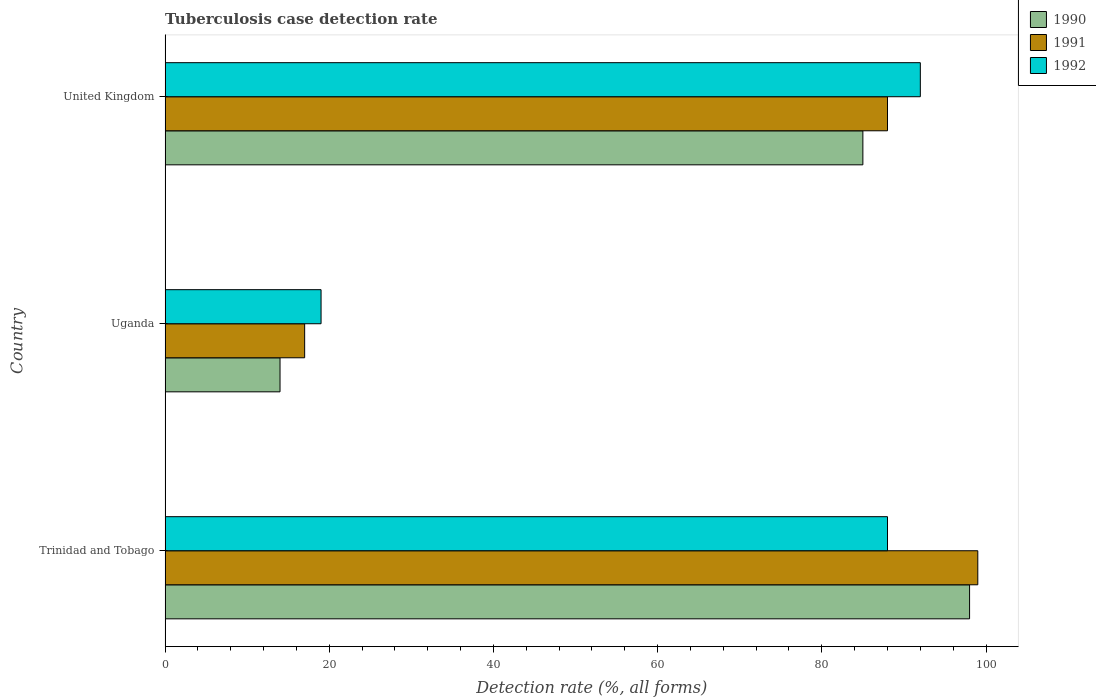How many groups of bars are there?
Offer a very short reply. 3. Are the number of bars per tick equal to the number of legend labels?
Provide a short and direct response. Yes. How many bars are there on the 2nd tick from the bottom?
Ensure brevity in your answer.  3. What is the label of the 3rd group of bars from the top?
Give a very brief answer. Trinidad and Tobago. In how many cases, is the number of bars for a given country not equal to the number of legend labels?
Ensure brevity in your answer.  0. Across all countries, what is the minimum tuberculosis case detection rate in in 1990?
Your answer should be very brief. 14. In which country was the tuberculosis case detection rate in in 1992 maximum?
Provide a short and direct response. United Kingdom. In which country was the tuberculosis case detection rate in in 1990 minimum?
Your response must be concise. Uganda. What is the total tuberculosis case detection rate in in 1990 in the graph?
Ensure brevity in your answer.  197. What is the difference between the tuberculosis case detection rate in in 1990 in Uganda and that in United Kingdom?
Provide a short and direct response. -71. What is the difference between the tuberculosis case detection rate in in 1990 in Uganda and the tuberculosis case detection rate in in 1992 in United Kingdom?
Ensure brevity in your answer.  -78. What is the average tuberculosis case detection rate in in 1992 per country?
Make the answer very short. 66.33. What is the difference between the tuberculosis case detection rate in in 1992 and tuberculosis case detection rate in in 1990 in Trinidad and Tobago?
Provide a succinct answer. -10. What is the ratio of the tuberculosis case detection rate in in 1990 in Uganda to that in United Kingdom?
Offer a terse response. 0.16. Is the tuberculosis case detection rate in in 1992 in Trinidad and Tobago less than that in United Kingdom?
Offer a terse response. Yes. Is the difference between the tuberculosis case detection rate in in 1992 in Uganda and United Kingdom greater than the difference between the tuberculosis case detection rate in in 1990 in Uganda and United Kingdom?
Your answer should be compact. No. What is the difference between the highest and the lowest tuberculosis case detection rate in in 1990?
Give a very brief answer. 84. What does the 1st bar from the bottom in Uganda represents?
Provide a succinct answer. 1990. Is it the case that in every country, the sum of the tuberculosis case detection rate in in 1992 and tuberculosis case detection rate in in 1991 is greater than the tuberculosis case detection rate in in 1990?
Your answer should be very brief. Yes. How many countries are there in the graph?
Keep it short and to the point. 3. Does the graph contain any zero values?
Your answer should be very brief. No. Does the graph contain grids?
Give a very brief answer. No. What is the title of the graph?
Provide a succinct answer. Tuberculosis case detection rate. Does "1995" appear as one of the legend labels in the graph?
Provide a short and direct response. No. What is the label or title of the X-axis?
Your response must be concise. Detection rate (%, all forms). What is the Detection rate (%, all forms) in 1990 in Trinidad and Tobago?
Your answer should be very brief. 98. What is the Detection rate (%, all forms) in 1991 in Trinidad and Tobago?
Your answer should be compact. 99. What is the Detection rate (%, all forms) of 1992 in Trinidad and Tobago?
Give a very brief answer. 88. What is the Detection rate (%, all forms) of 1991 in Uganda?
Offer a terse response. 17. What is the Detection rate (%, all forms) of 1992 in United Kingdom?
Offer a very short reply. 92. Across all countries, what is the maximum Detection rate (%, all forms) in 1992?
Give a very brief answer. 92. Across all countries, what is the minimum Detection rate (%, all forms) in 1992?
Offer a terse response. 19. What is the total Detection rate (%, all forms) of 1990 in the graph?
Make the answer very short. 197. What is the total Detection rate (%, all forms) of 1991 in the graph?
Ensure brevity in your answer.  204. What is the total Detection rate (%, all forms) of 1992 in the graph?
Your response must be concise. 199. What is the difference between the Detection rate (%, all forms) in 1990 in Trinidad and Tobago and that in Uganda?
Your response must be concise. 84. What is the difference between the Detection rate (%, all forms) of 1991 in Trinidad and Tobago and that in Uganda?
Offer a very short reply. 82. What is the difference between the Detection rate (%, all forms) of 1992 in Trinidad and Tobago and that in Uganda?
Your answer should be very brief. 69. What is the difference between the Detection rate (%, all forms) in 1990 in Trinidad and Tobago and that in United Kingdom?
Offer a terse response. 13. What is the difference between the Detection rate (%, all forms) in 1991 in Trinidad and Tobago and that in United Kingdom?
Provide a short and direct response. 11. What is the difference between the Detection rate (%, all forms) of 1992 in Trinidad and Tobago and that in United Kingdom?
Provide a succinct answer. -4. What is the difference between the Detection rate (%, all forms) in 1990 in Uganda and that in United Kingdom?
Make the answer very short. -71. What is the difference between the Detection rate (%, all forms) in 1991 in Uganda and that in United Kingdom?
Give a very brief answer. -71. What is the difference between the Detection rate (%, all forms) of 1992 in Uganda and that in United Kingdom?
Offer a terse response. -73. What is the difference between the Detection rate (%, all forms) of 1990 in Trinidad and Tobago and the Detection rate (%, all forms) of 1992 in Uganda?
Your answer should be very brief. 79. What is the difference between the Detection rate (%, all forms) of 1991 in Trinidad and Tobago and the Detection rate (%, all forms) of 1992 in Uganda?
Make the answer very short. 80. What is the difference between the Detection rate (%, all forms) of 1990 in Trinidad and Tobago and the Detection rate (%, all forms) of 1991 in United Kingdom?
Provide a short and direct response. 10. What is the difference between the Detection rate (%, all forms) of 1990 in Trinidad and Tobago and the Detection rate (%, all forms) of 1992 in United Kingdom?
Keep it short and to the point. 6. What is the difference between the Detection rate (%, all forms) of 1991 in Trinidad and Tobago and the Detection rate (%, all forms) of 1992 in United Kingdom?
Keep it short and to the point. 7. What is the difference between the Detection rate (%, all forms) in 1990 in Uganda and the Detection rate (%, all forms) in 1991 in United Kingdom?
Your answer should be compact. -74. What is the difference between the Detection rate (%, all forms) in 1990 in Uganda and the Detection rate (%, all forms) in 1992 in United Kingdom?
Offer a very short reply. -78. What is the difference between the Detection rate (%, all forms) of 1991 in Uganda and the Detection rate (%, all forms) of 1992 in United Kingdom?
Ensure brevity in your answer.  -75. What is the average Detection rate (%, all forms) of 1990 per country?
Offer a very short reply. 65.67. What is the average Detection rate (%, all forms) of 1992 per country?
Offer a very short reply. 66.33. What is the difference between the Detection rate (%, all forms) in 1991 and Detection rate (%, all forms) in 1992 in Trinidad and Tobago?
Offer a very short reply. 11. What is the difference between the Detection rate (%, all forms) in 1990 and Detection rate (%, all forms) in 1991 in Uganda?
Give a very brief answer. -3. What is the difference between the Detection rate (%, all forms) of 1990 and Detection rate (%, all forms) of 1992 in Uganda?
Make the answer very short. -5. What is the difference between the Detection rate (%, all forms) in 1991 and Detection rate (%, all forms) in 1992 in United Kingdom?
Keep it short and to the point. -4. What is the ratio of the Detection rate (%, all forms) of 1990 in Trinidad and Tobago to that in Uganda?
Give a very brief answer. 7. What is the ratio of the Detection rate (%, all forms) in 1991 in Trinidad and Tobago to that in Uganda?
Ensure brevity in your answer.  5.82. What is the ratio of the Detection rate (%, all forms) of 1992 in Trinidad and Tobago to that in Uganda?
Your answer should be very brief. 4.63. What is the ratio of the Detection rate (%, all forms) of 1990 in Trinidad and Tobago to that in United Kingdom?
Provide a succinct answer. 1.15. What is the ratio of the Detection rate (%, all forms) in 1992 in Trinidad and Tobago to that in United Kingdom?
Offer a terse response. 0.96. What is the ratio of the Detection rate (%, all forms) of 1990 in Uganda to that in United Kingdom?
Keep it short and to the point. 0.16. What is the ratio of the Detection rate (%, all forms) in 1991 in Uganda to that in United Kingdom?
Your answer should be very brief. 0.19. What is the ratio of the Detection rate (%, all forms) of 1992 in Uganda to that in United Kingdom?
Your response must be concise. 0.21. What is the difference between the highest and the second highest Detection rate (%, all forms) of 1991?
Offer a terse response. 11. What is the difference between the highest and the second highest Detection rate (%, all forms) of 1992?
Make the answer very short. 4. What is the difference between the highest and the lowest Detection rate (%, all forms) of 1991?
Make the answer very short. 82. What is the difference between the highest and the lowest Detection rate (%, all forms) in 1992?
Offer a terse response. 73. 